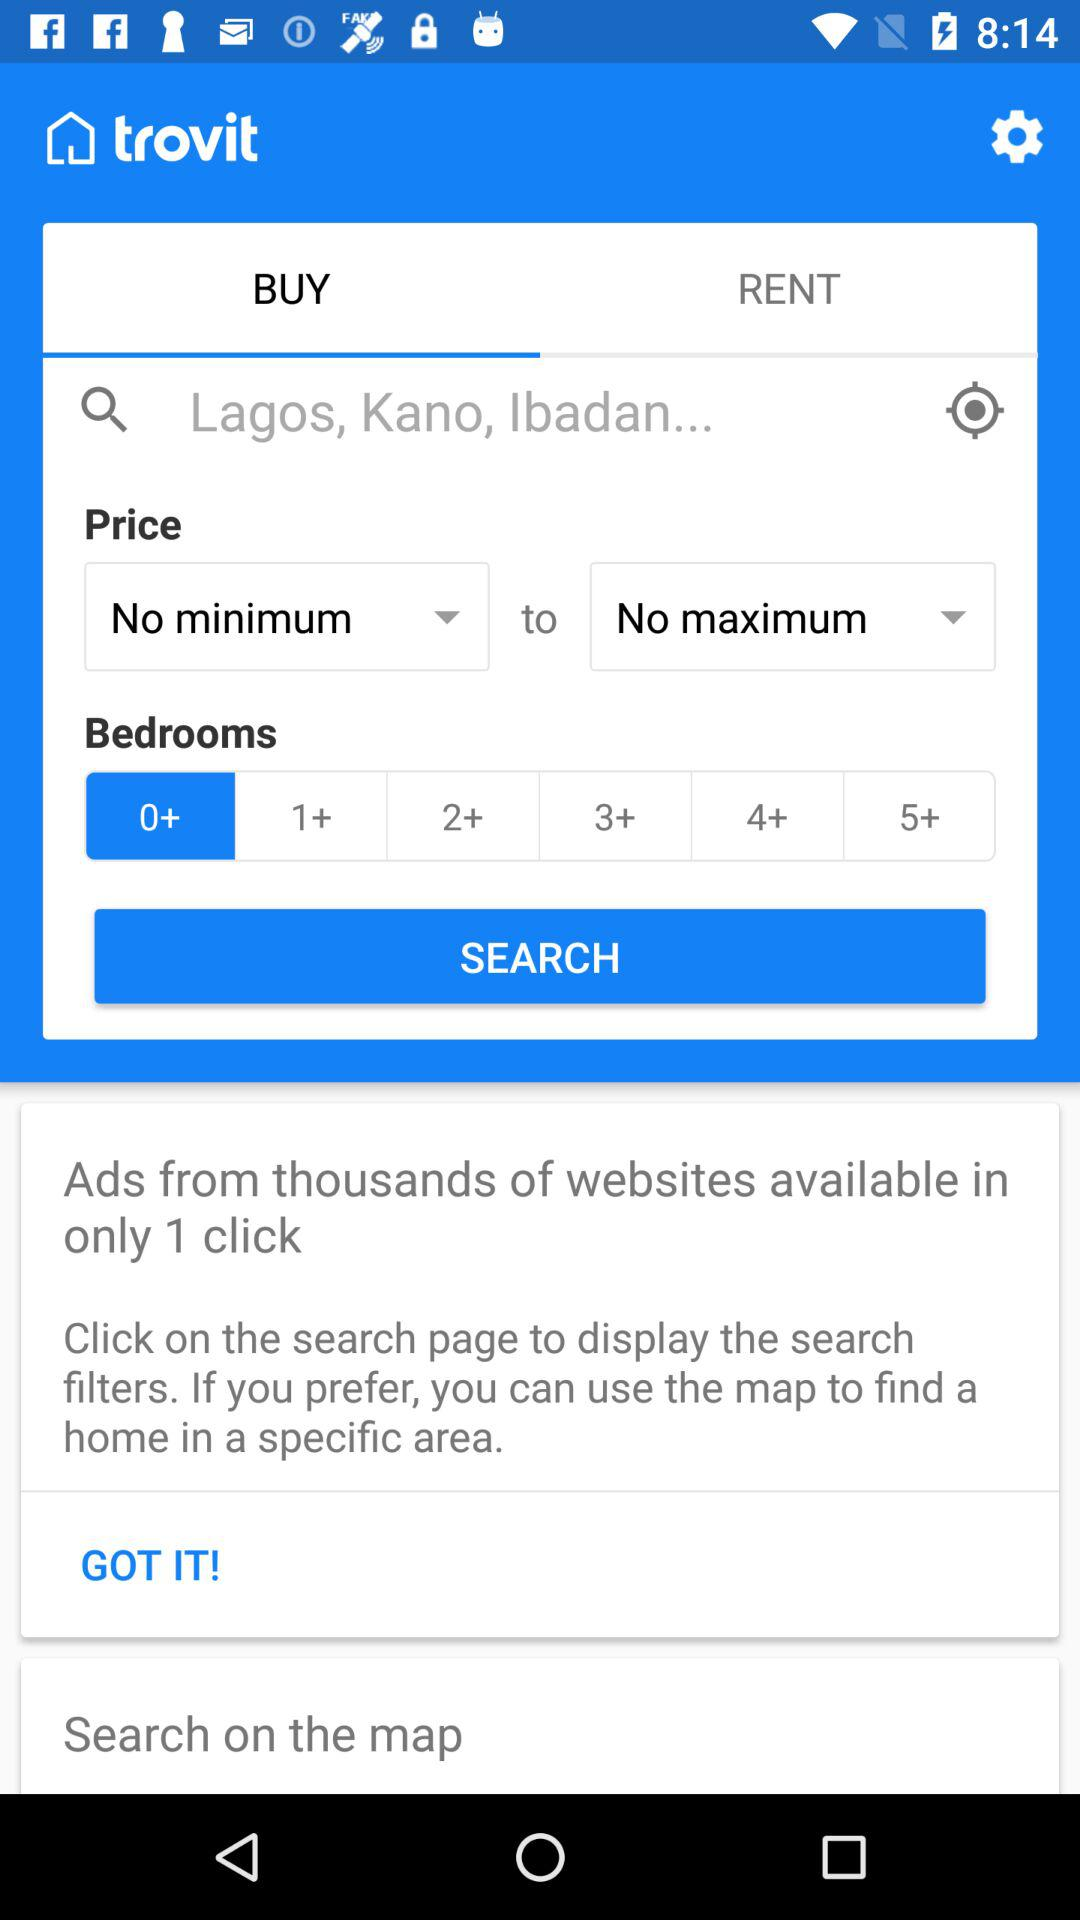What is the mentioned location? The mentioned locations are Lagos, Kano and Ibadan. 